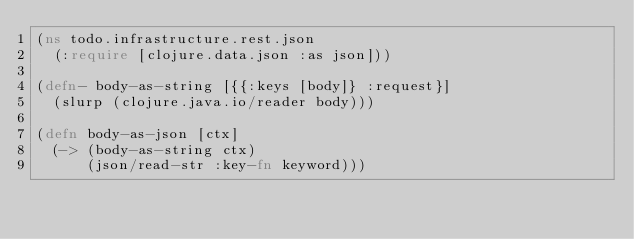<code> <loc_0><loc_0><loc_500><loc_500><_Clojure_>(ns todo.infrastructure.rest.json
  (:require [clojure.data.json :as json]))

(defn- body-as-string [{{:keys [body]} :request}]
  (slurp (clojure.java.io/reader body)))

(defn body-as-json [ctx]
  (-> (body-as-string ctx)
      (json/read-str :key-fn keyword)))
</code> 